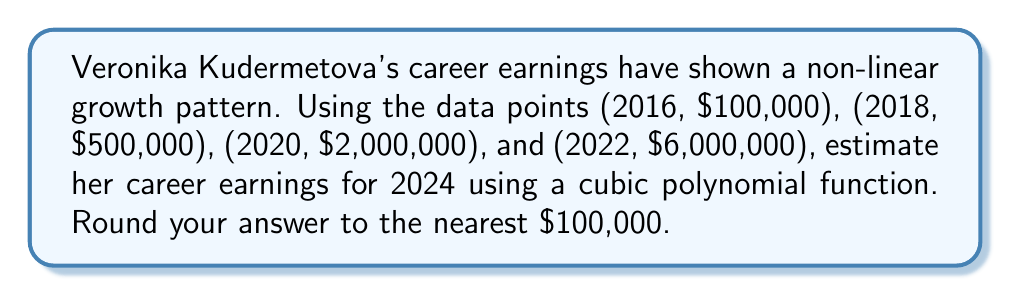Provide a solution to this math problem. To estimate Veronika Kudermetova's career earnings for 2024 using a cubic polynomial function, we'll follow these steps:

1) Let's define our cubic function as:
   $$f(x) = ax^3 + bx^2 + cx + d$$
   where $x$ represents the number of years since 2016.

2) We have four data points:
   (0, 100000), (2, 500000), (4, 2000000), (6, 6000000)

3) Substituting these into our function:
   $$100000 = d$$
   $$500000 = 8a + 4b + 2c + 100000$$
   $$2000000 = 64a + 16b + 4c + 100000$$
   $$6000000 = 216a + 36b + 6c + 100000$$

4) Subtracting the first equation from the others:
   $$400000 = 8a + 4b + 2c$$
   $$1900000 = 64a + 16b + 4c$$
   $$5900000 = 216a + 36b + 6c$$

5) Using a system of equations solver or matrix operations, we find:
   $$a = 25000$$
   $$b = 25000$$
   $$c = 50000$$

6) Our cubic function is therefore:
   $$f(x) = 25000x^3 + 25000x^2 + 50000x + 100000$$

7) To estimate earnings for 2024, we calculate $f(8)$:
   $$f(8) = 25000(8^3) + 25000(8^2) + 50000(8) + 100000$$
   $$= 12800000 + 1600000 + 400000 + 100000$$
   $$= 14900000$$

8) Rounding to the nearest $100,000:
   $14,900,000 rounds to $14,900,000
Answer: $14,900,000 